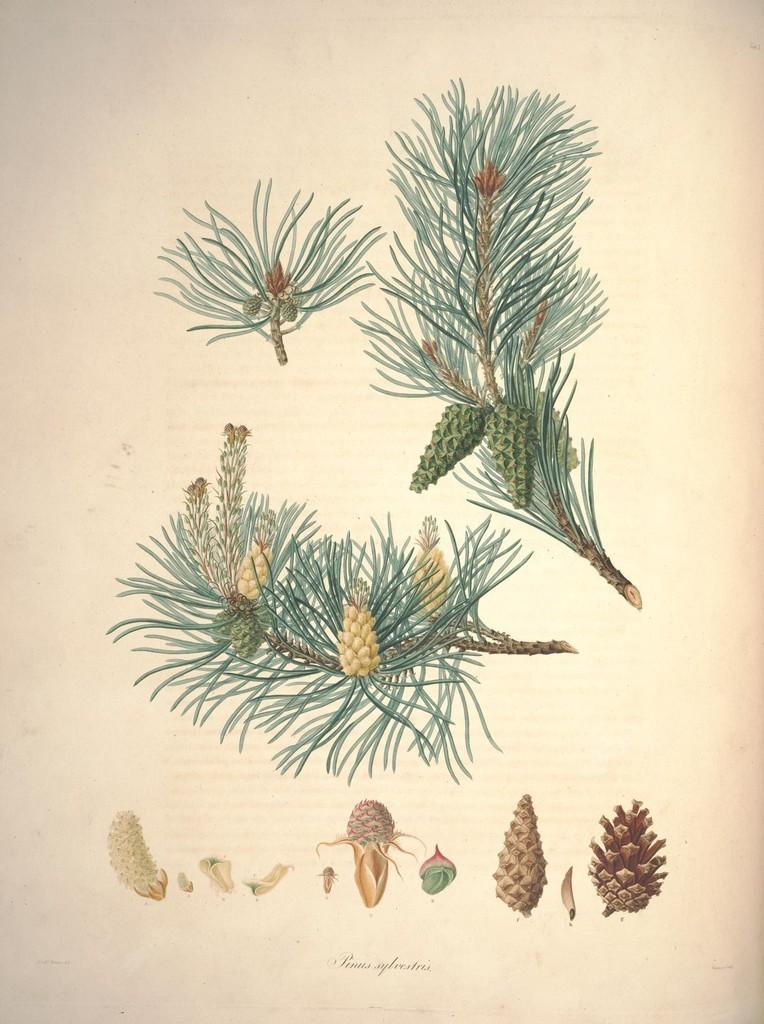What type of living organisms can be seen in the image? Plants and flowers are visible in the image. What can be found on the plants in the image? There are fruit-like eatables and seeds in the image. What is the medium of the image? The image appears to be a drawing on paper. What type of metal is used to create the wheel in the image? There is no wheel present in the image, so it is not possible to determine the type of metal used. 